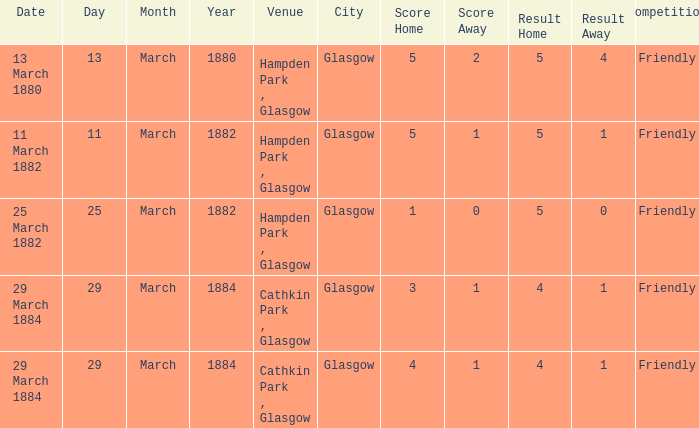Which competition had a 4-1 result, and a score of 4-1? Friendly. 